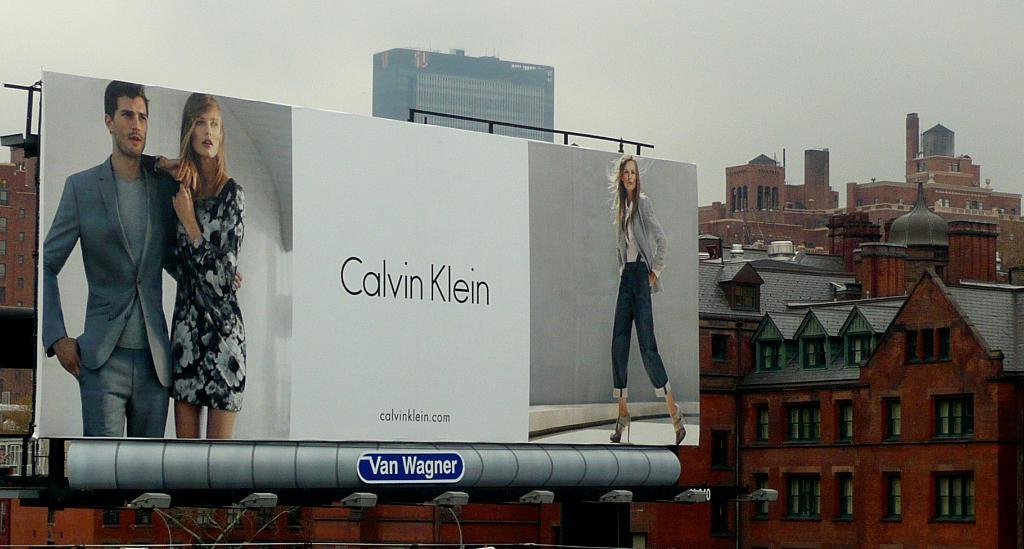<image>
Offer a succinct explanation of the picture presented. a billboard that is promoting calvin klein on it 